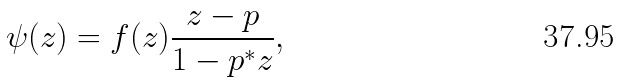<formula> <loc_0><loc_0><loc_500><loc_500>\psi ( z ) = f ( z ) { \frac { z - p } { 1 - p ^ { * } z } } ,</formula> 